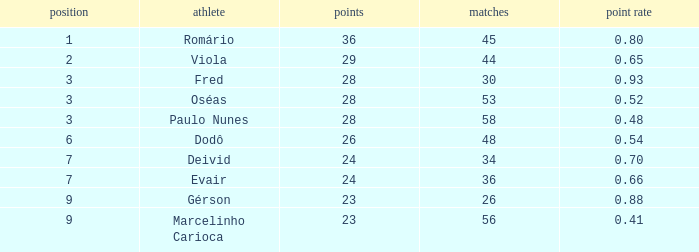How many goal ratios have rank of 2 with more than 44 games? 0.0. 